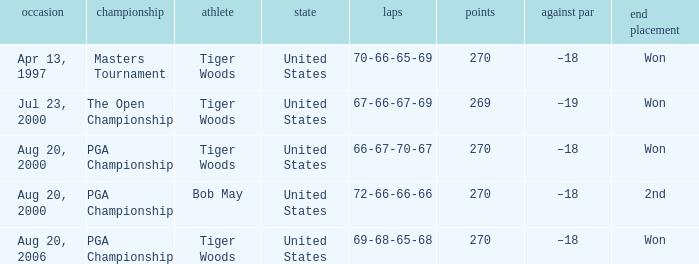What is the worst (highest) score? 270.0. 